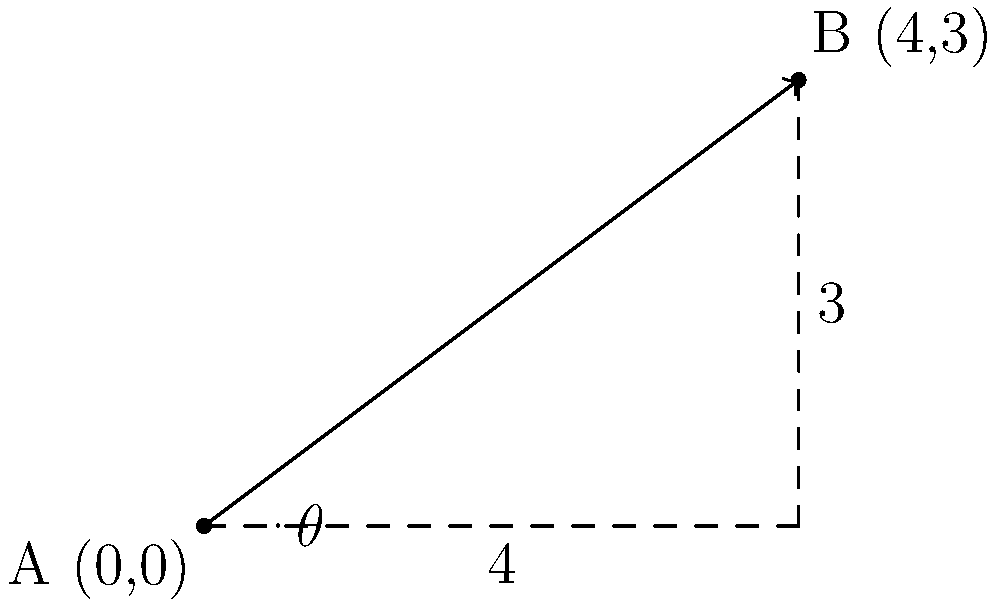You're helping your older sibling install a shelf, and they want to teach you about slope calculation. The shelf needs to be installed at a specific angle, represented by two points: A(0,0) and B(4,3) on a coordinate plane. Calculate the angle $\theta$ (in degrees) at which the shelf should be installed relative to the horizontal. To find the angle of the shelf installation, we'll follow these steps:

1) First, calculate the slope of the line connecting points A and B:
   $m = \frac{y_2 - y_1}{x_2 - x_1} = \frac{3 - 0}{4 - 0} = \frac{3}{4} = 0.75$

2) The slope represents the tangent of the angle $\theta$:
   $\tan(\theta) = 0.75$

3) To find $\theta$, we need to use the inverse tangent (arctangent) function:
   $\theta = \arctan(0.75)$

4) Calculate this value (you can use a calculator):
   $\theta \approx 36.87°$

5) Round to the nearest degree:
   $\theta \approx 37°$

Therefore, the shelf should be installed at an angle of approximately 37° relative to the horizontal.
Answer: 37° 